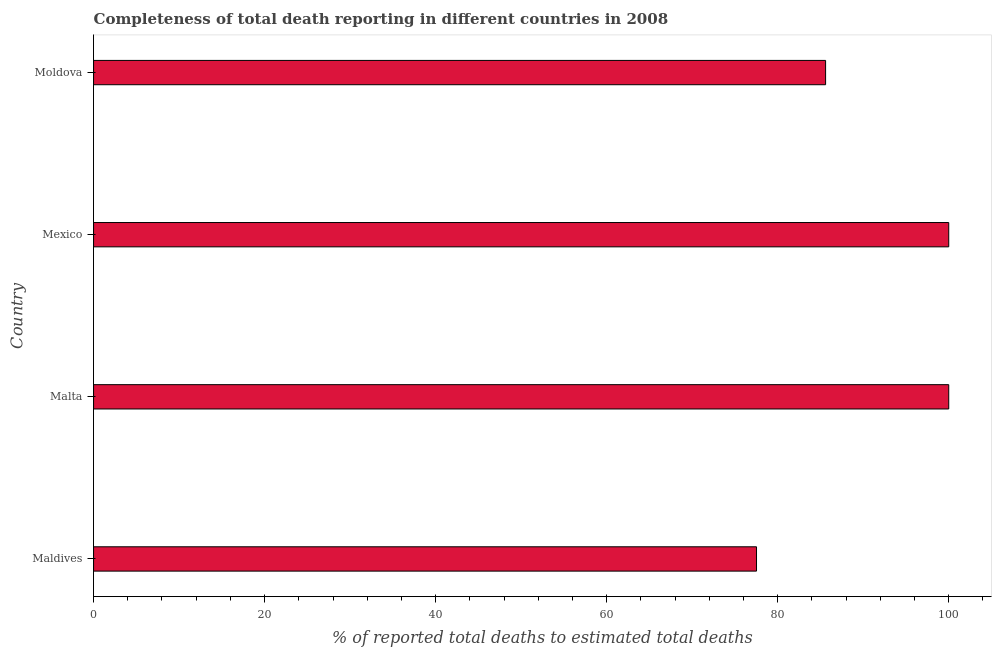What is the title of the graph?
Offer a very short reply. Completeness of total death reporting in different countries in 2008. What is the label or title of the X-axis?
Your response must be concise. % of reported total deaths to estimated total deaths. What is the completeness of total death reports in Moldova?
Your answer should be compact. 85.6. Across all countries, what is the minimum completeness of total death reports?
Your response must be concise. 77.52. In which country was the completeness of total death reports maximum?
Your response must be concise. Malta. In which country was the completeness of total death reports minimum?
Keep it short and to the point. Maldives. What is the sum of the completeness of total death reports?
Provide a succinct answer. 363.12. What is the difference between the completeness of total death reports in Malta and Mexico?
Your response must be concise. 0. What is the average completeness of total death reports per country?
Offer a very short reply. 90.78. What is the median completeness of total death reports?
Make the answer very short. 92.8. In how many countries, is the completeness of total death reports greater than 84 %?
Offer a very short reply. 3. What is the ratio of the completeness of total death reports in Malta to that in Moldova?
Offer a terse response. 1.17. Is the difference between the completeness of total death reports in Maldives and Moldova greater than the difference between any two countries?
Offer a terse response. No. What is the difference between the highest and the lowest completeness of total death reports?
Provide a succinct answer. 22.48. In how many countries, is the completeness of total death reports greater than the average completeness of total death reports taken over all countries?
Provide a short and direct response. 2. How many bars are there?
Make the answer very short. 4. What is the difference between two consecutive major ticks on the X-axis?
Provide a short and direct response. 20. Are the values on the major ticks of X-axis written in scientific E-notation?
Ensure brevity in your answer.  No. What is the % of reported total deaths to estimated total deaths of Maldives?
Offer a very short reply. 77.52. What is the % of reported total deaths to estimated total deaths in Mexico?
Ensure brevity in your answer.  100. What is the % of reported total deaths to estimated total deaths of Moldova?
Provide a succinct answer. 85.6. What is the difference between the % of reported total deaths to estimated total deaths in Maldives and Malta?
Give a very brief answer. -22.48. What is the difference between the % of reported total deaths to estimated total deaths in Maldives and Mexico?
Keep it short and to the point. -22.48. What is the difference between the % of reported total deaths to estimated total deaths in Maldives and Moldova?
Give a very brief answer. -8.08. What is the difference between the % of reported total deaths to estimated total deaths in Malta and Moldova?
Keep it short and to the point. 14.4. What is the difference between the % of reported total deaths to estimated total deaths in Mexico and Moldova?
Give a very brief answer. 14.4. What is the ratio of the % of reported total deaths to estimated total deaths in Maldives to that in Malta?
Ensure brevity in your answer.  0.78. What is the ratio of the % of reported total deaths to estimated total deaths in Maldives to that in Mexico?
Ensure brevity in your answer.  0.78. What is the ratio of the % of reported total deaths to estimated total deaths in Maldives to that in Moldova?
Your response must be concise. 0.91. What is the ratio of the % of reported total deaths to estimated total deaths in Malta to that in Moldova?
Provide a short and direct response. 1.17. What is the ratio of the % of reported total deaths to estimated total deaths in Mexico to that in Moldova?
Your response must be concise. 1.17. 